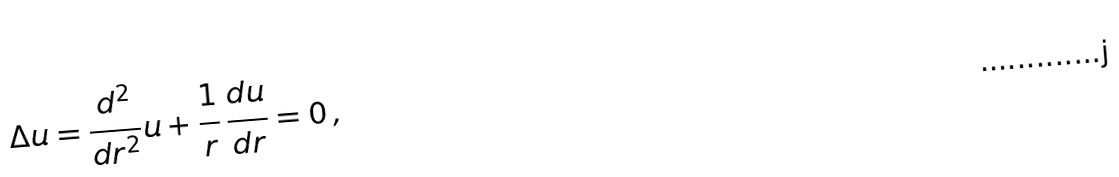<formula> <loc_0><loc_0><loc_500><loc_500>\Delta u = \frac { d ^ { 2 } } { d r ^ { 2 } } u + \frac { 1 } { r } \, \frac { d u } { d r } = 0 \, ,</formula> 